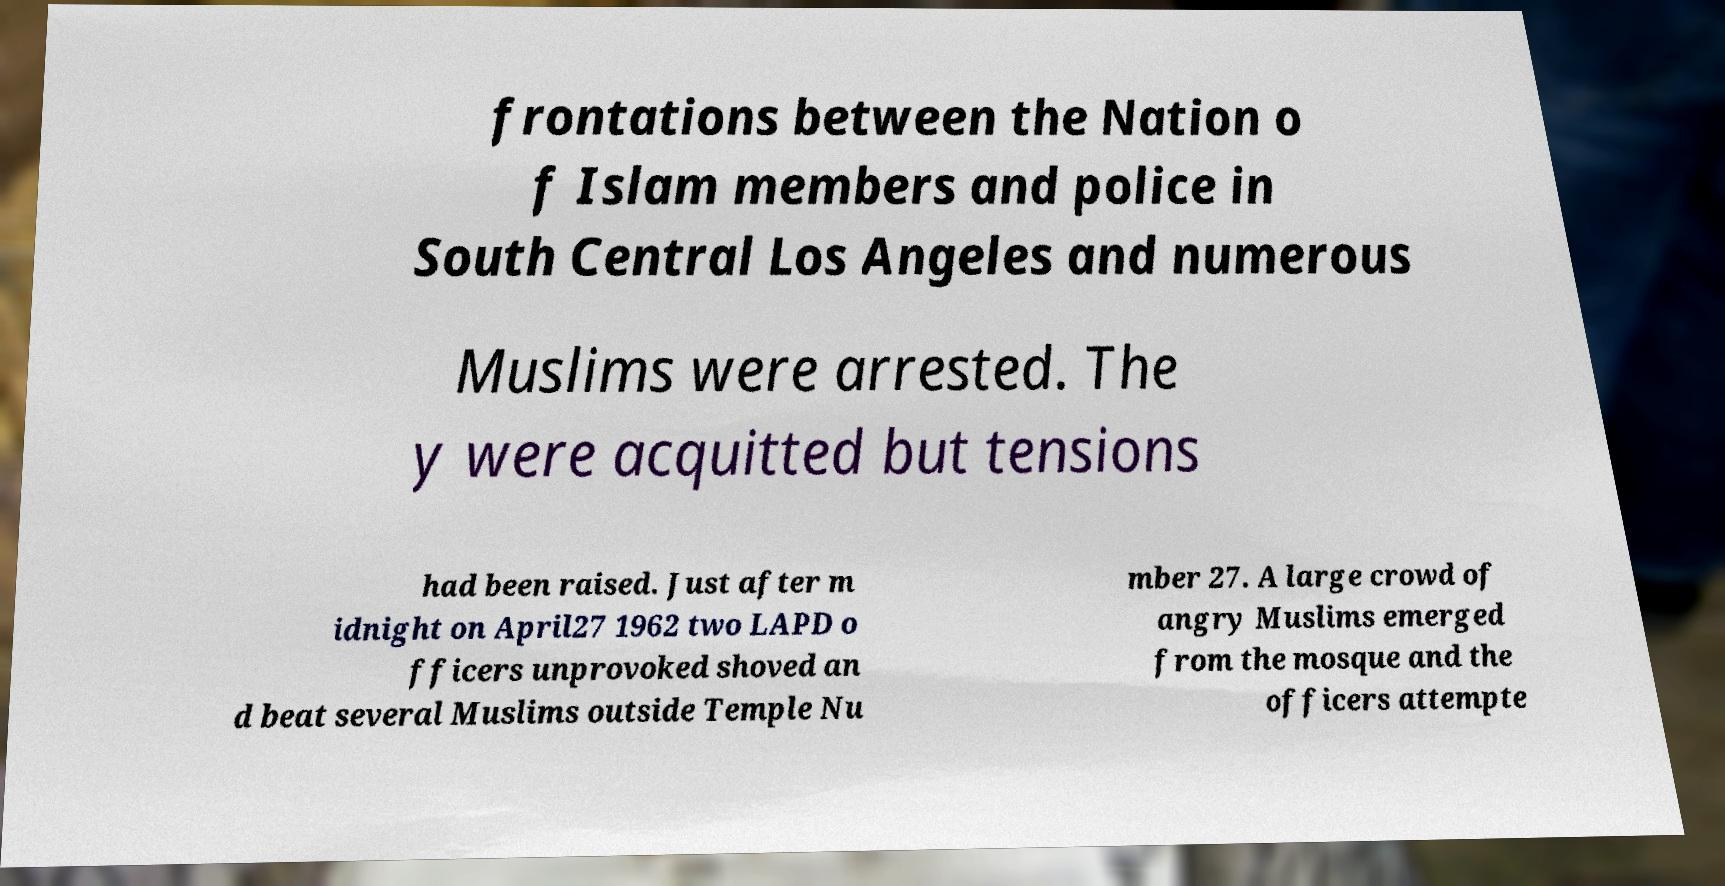Could you extract and type out the text from this image? frontations between the Nation o f Islam members and police in South Central Los Angeles and numerous Muslims were arrested. The y were acquitted but tensions had been raised. Just after m idnight on April27 1962 two LAPD o fficers unprovoked shoved an d beat several Muslims outside Temple Nu mber 27. A large crowd of angry Muslims emerged from the mosque and the officers attempte 